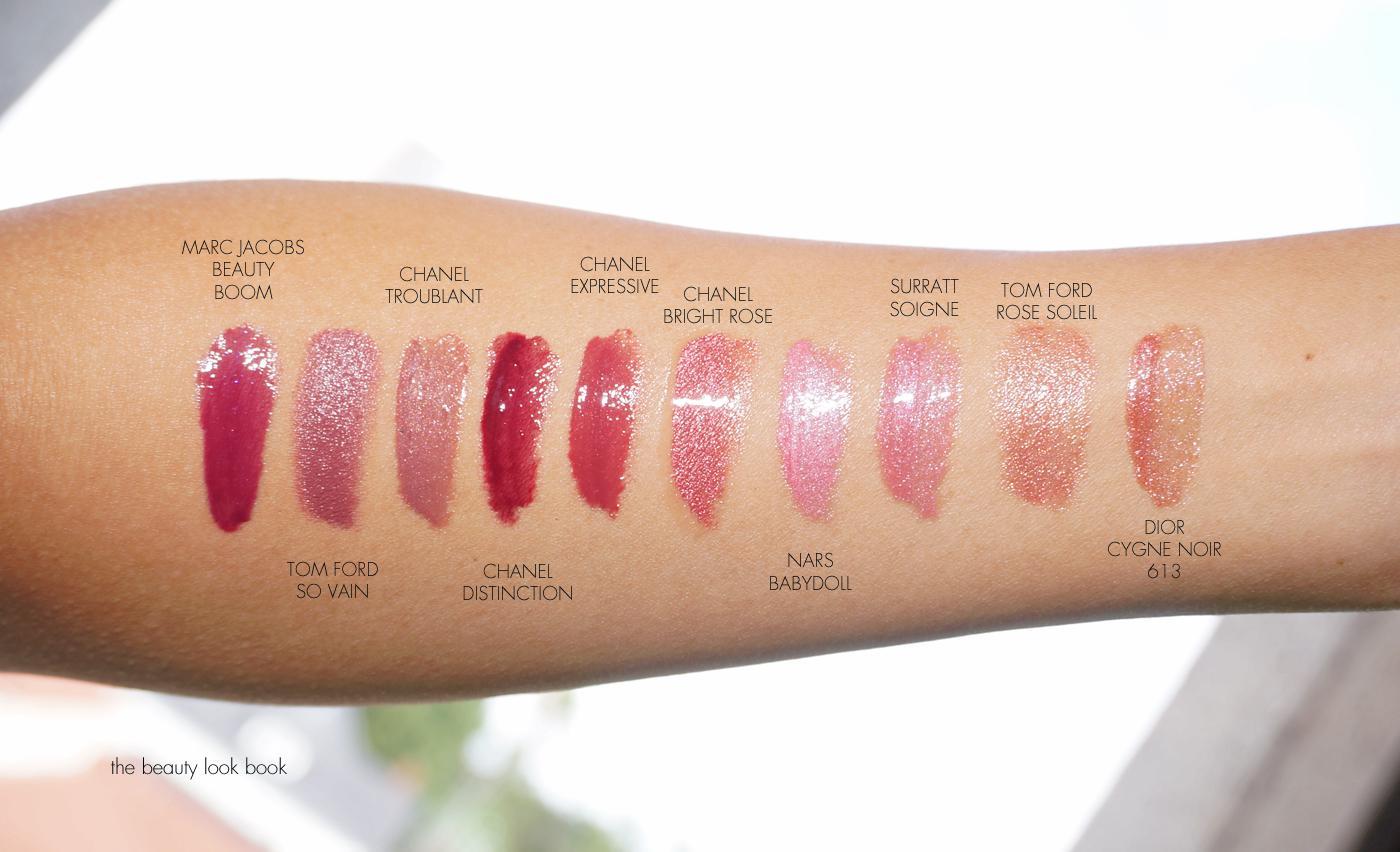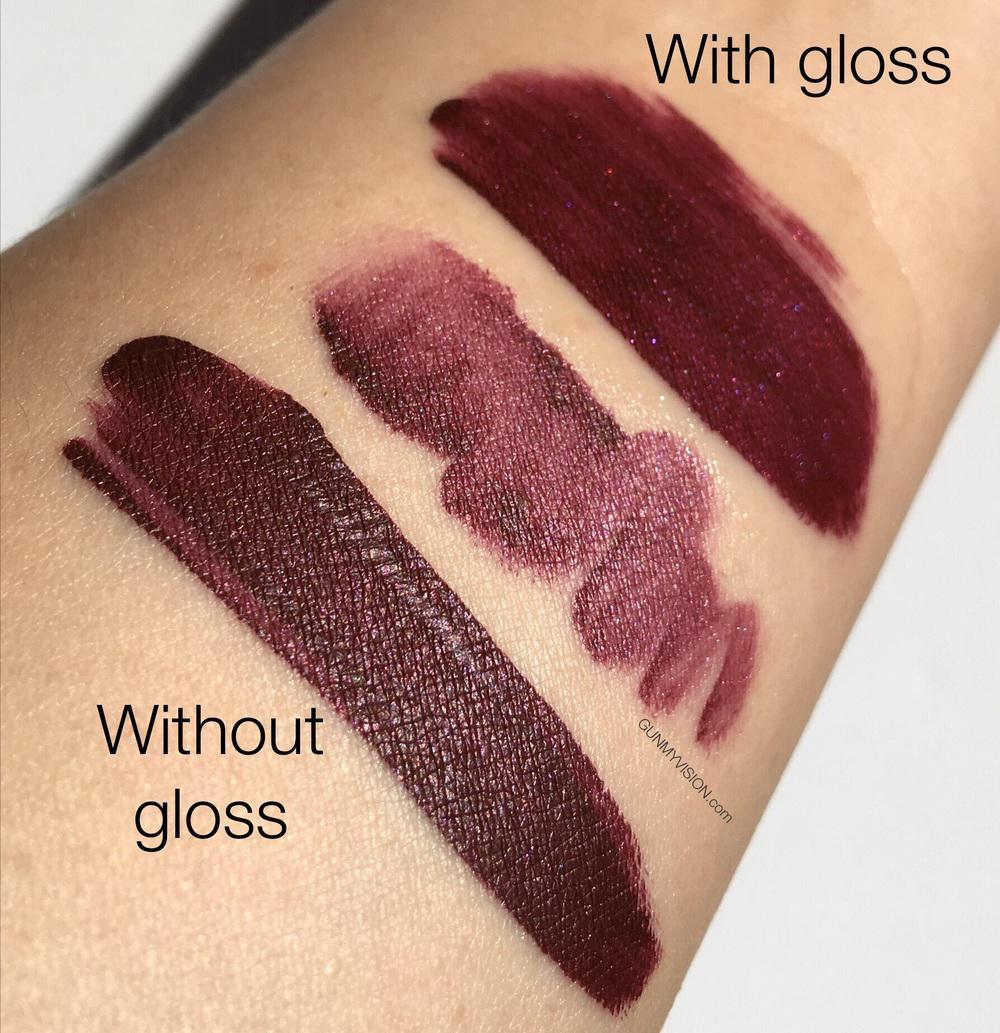The first image is the image on the left, the second image is the image on the right. For the images displayed, is the sentence "One picture shows six or more pigments of lipstick swatched on a human arm." factually correct? Answer yes or no. Yes. The first image is the image on the left, the second image is the image on the right. Evaluate the accuracy of this statement regarding the images: "In each image, different shades of lipstick are displayed alongside each other on a human arm". Is it true? Answer yes or no. Yes. 